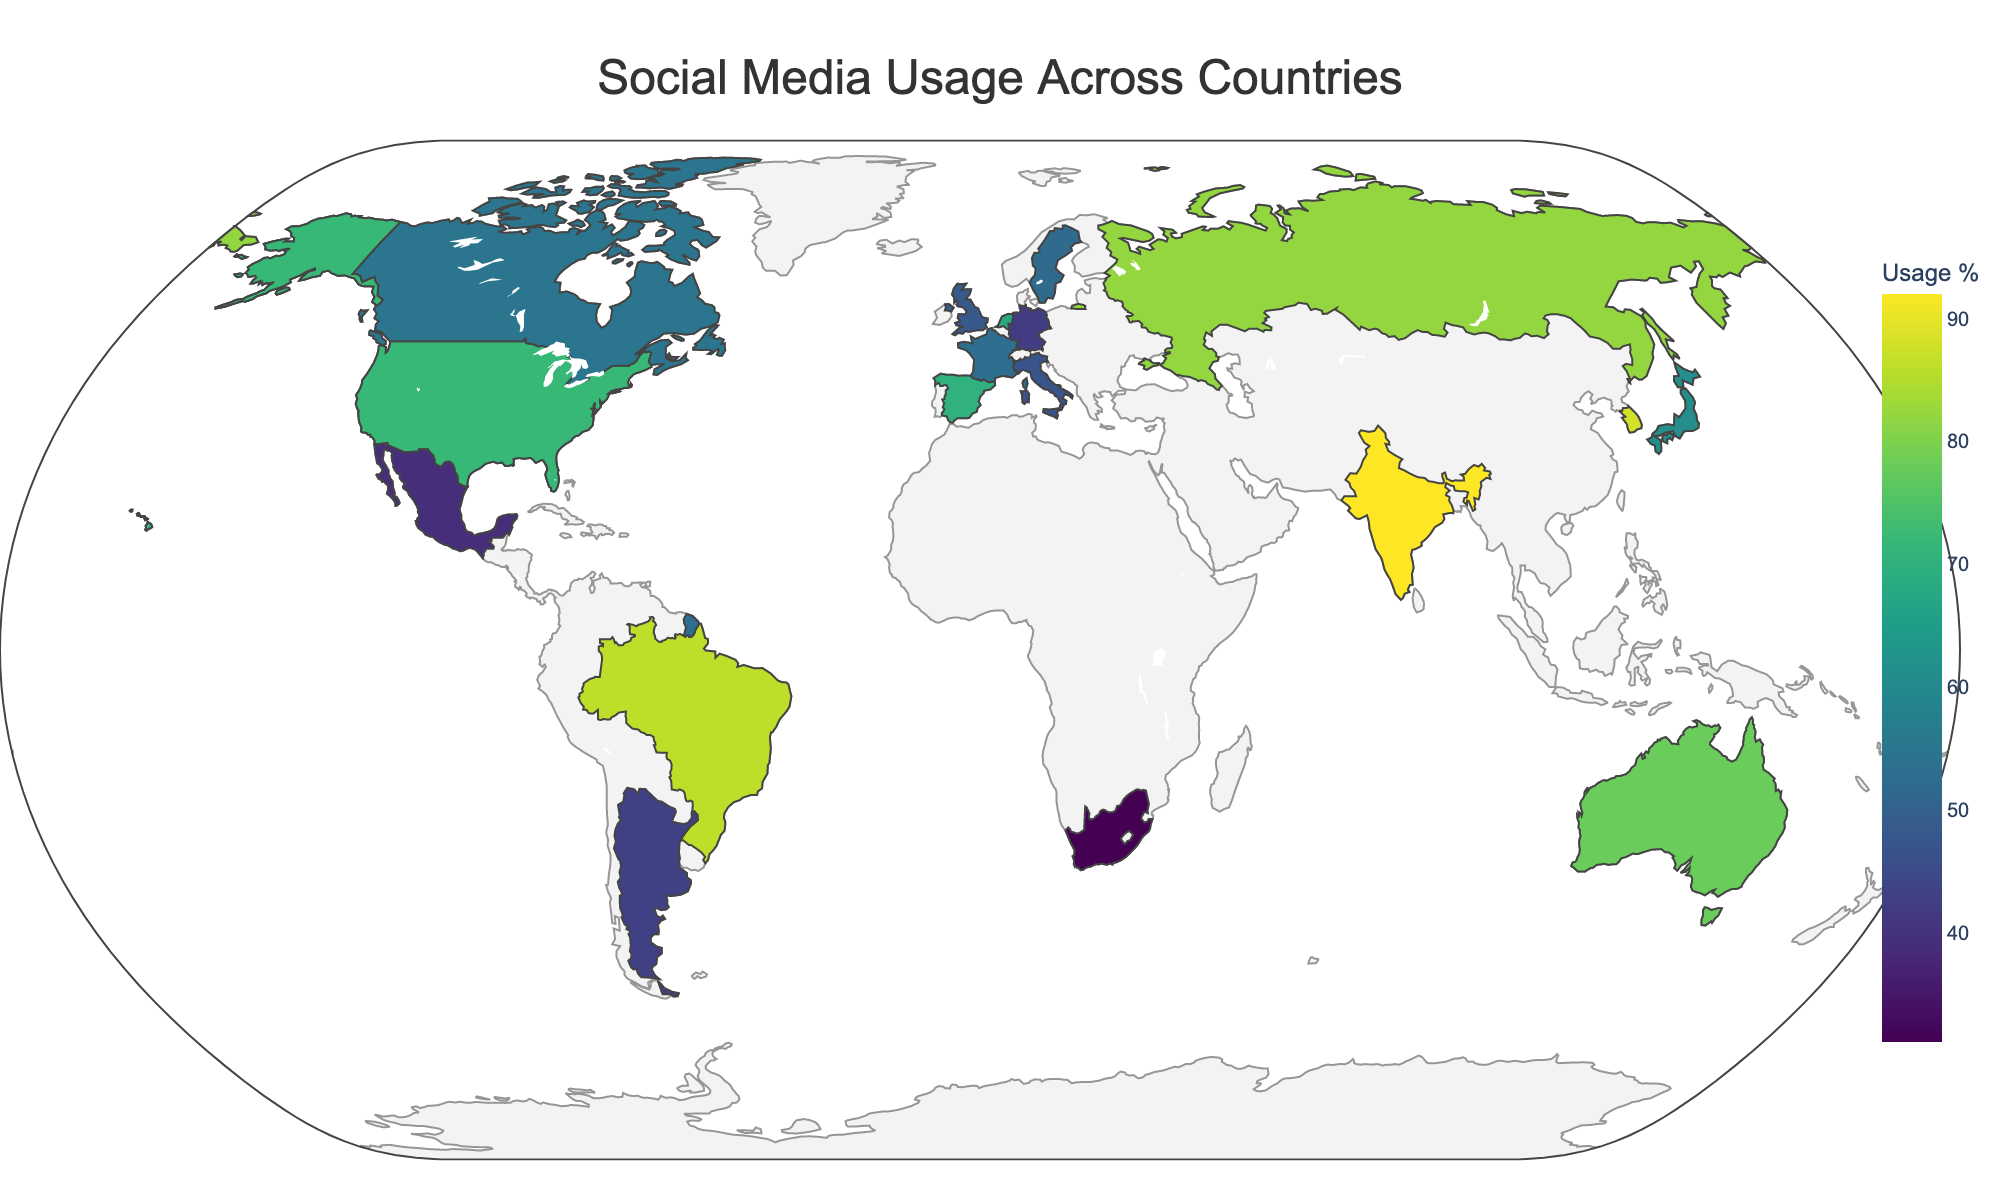What is the title of the figure? The title of the figure is visually apparent at the top of the map.
Answer: Social Media Usage Across Countries Which country has the highest usage percentage, and what is the platform associated with it? Look for the country with the darkest color, indicating the highest percentage, and refer to the hover data to find the platform. India, shown in the darkest color, has the highest usage percentage, and the platform is YouTube.
Answer: India, YouTube How does the usage percentage of TikTok in Australia compare to that in Spain for the same age group? Check the colors and hover over both Australia and Spain on the map. Compare the percentages shown in the hover data for the 18-24 age group. Australia shows a usage percentage of 78% for TikTok, whereas Spain shows 70% for the same platform and age group.
Answer: Australia is higher Which social media platform has the highest usage percentage among the 25-34 age group, and in which country? Identify the countries and platforms within the 25-34 age group, then find the highest percentage among them. Russia's VKontakte for the 25-34 age group has the highest usage percentage of 82%.
Answer: VKontakte, Russia Among the 18-24 age group, which country has the lowest social media usage and what is the platform? Check the hover data for countries in the 18-24 age group and identify the lowest percentage. The United States, with Facebook, has the lowest percentage of 65%.
Answer: United States, Facebook What is the average social media usage percentage for the 35-44 age group across all countries? Find all the data points for the 35-44 age group, sum their usage percentages, and divide by the number of data points. The percentages for 35-44 are: 48 (UK) + 86 (Brazil) + 79 (Singapore) + 47 (Italy) = 260. There are 4 data points, so the average is 260 / 4 = 65%.
Answer: 65% How many countries have their highest usage percentage with Twitter, regardless of age group? Check the hover data for each country, noting those with Twitter and seeing if it's the highest usage percentage for that country. The countries are: United Kingdom (48%), South Africa (31%), and Argentina (43%).
Answer: 3 Which country and platform combination shows the lowest social media usage? Identify the country and platform with the lightest color on the map, indicating the lowest usage percentage, and verify by hovering over the data points. South Africa shows the lowest usage with Twitter at 31%.
Answer: South Africa, Twitter Is there a noticeable pattern for a specific age group in terms of high or low usage percentages across different countries? Examine the colors for the different age groups across the map. The 18-24 age group tends to have higher usage percentages across several platforms (e.g., India, Australia, South Korea) compared to older age groups.
Answer: 18-24 age group tends to have higher usage Which platform is used most widely across different countries and age groups? Look for the platform mentioned most frequently in the hover data across different countries and age groups. The most widely mentioned platform across various data points is Instagram, appearing in the United States, Japan, and Sweden.
Answer: Instagram 